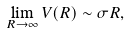<formula> <loc_0><loc_0><loc_500><loc_500>\lim _ { R \rightarrow \infty } V ( R ) \sim \sigma R ,</formula> 